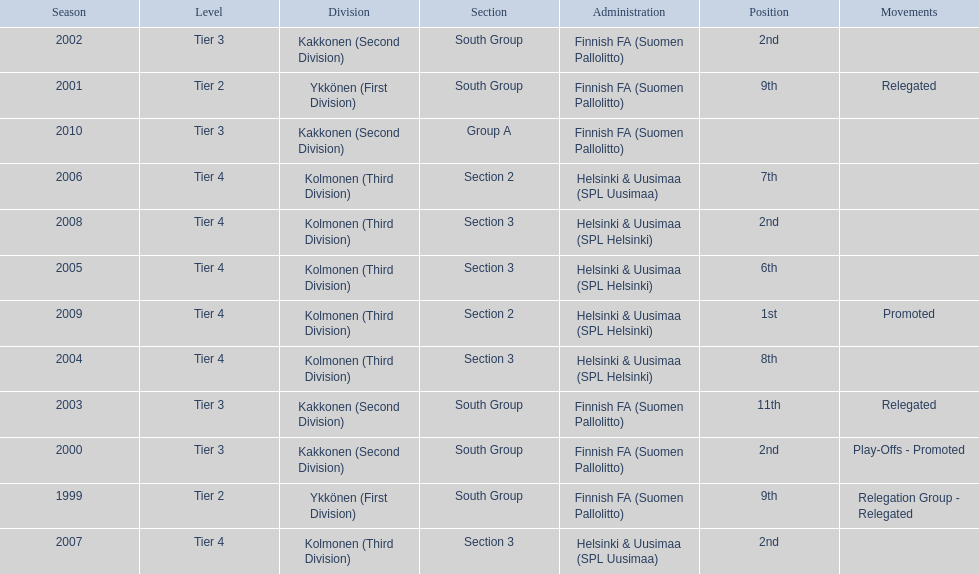In which tiers did more than one relegated movement occur? 1. 